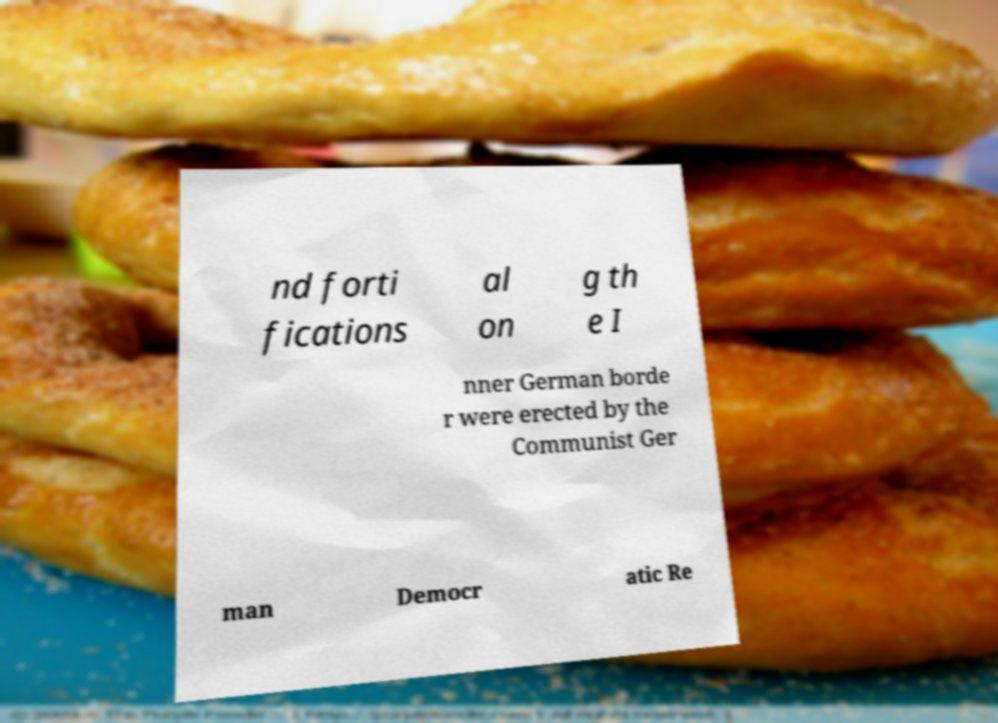Can you accurately transcribe the text from the provided image for me? nd forti fications al on g th e I nner German borde r were erected by the Communist Ger man Democr atic Re 